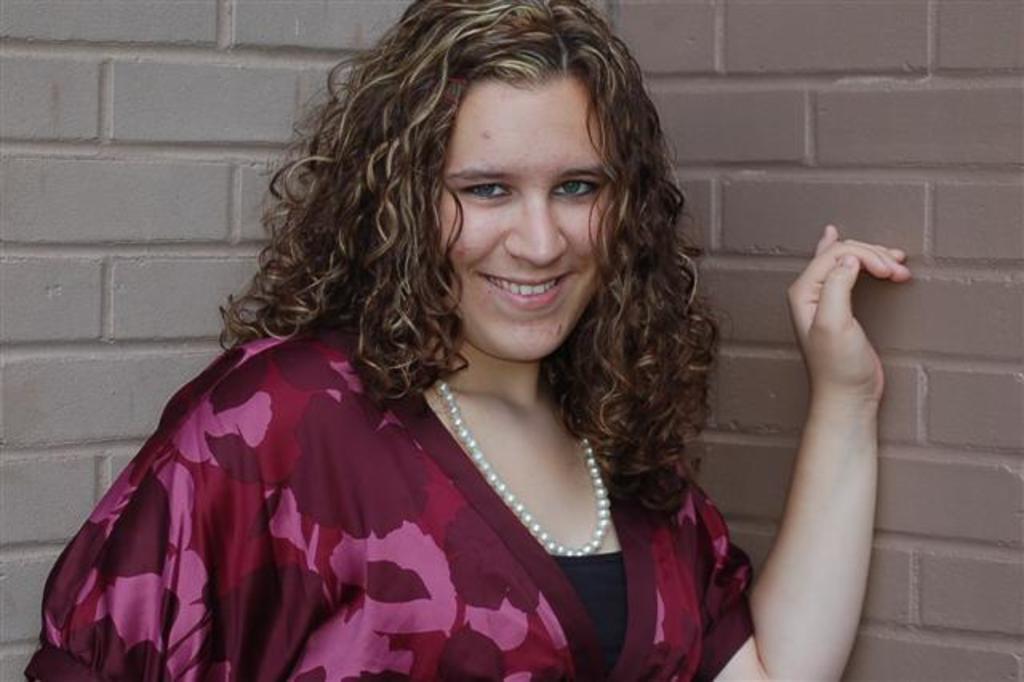Please provide a concise description of this image. In this image I can see a woman is smiling. The woman is wearing a necklace. In the background I can see a wall. 